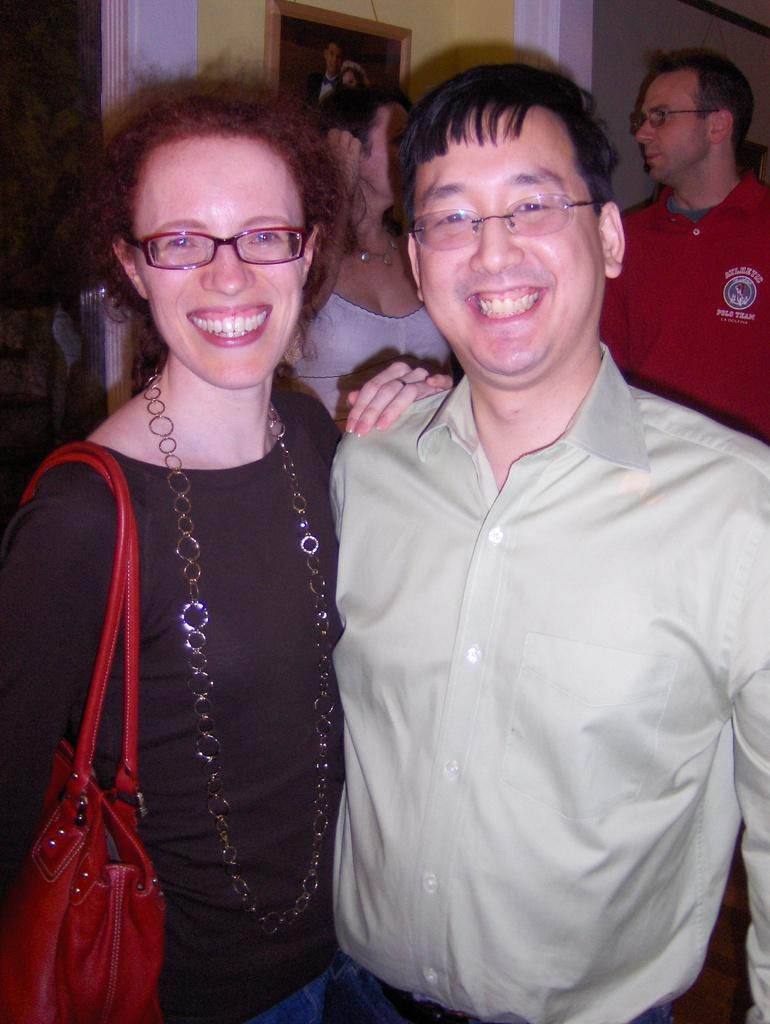How many persons are present in the image? There are persons standing in the image. What is the facial expression of some of the persons? Two of the persons are smiling. What accessory do two of the persons have in common? Two of the persons are wearing glasses. What is one person carrying in the image? One person is wearing a bag. What can be seen in the background of the image? There is a wall and a frame in the background of the image. What type of kitten can be seen playing with the wind in the image? There is no kitten or wind present in the image; it features persons standing with specific details mentioned. 